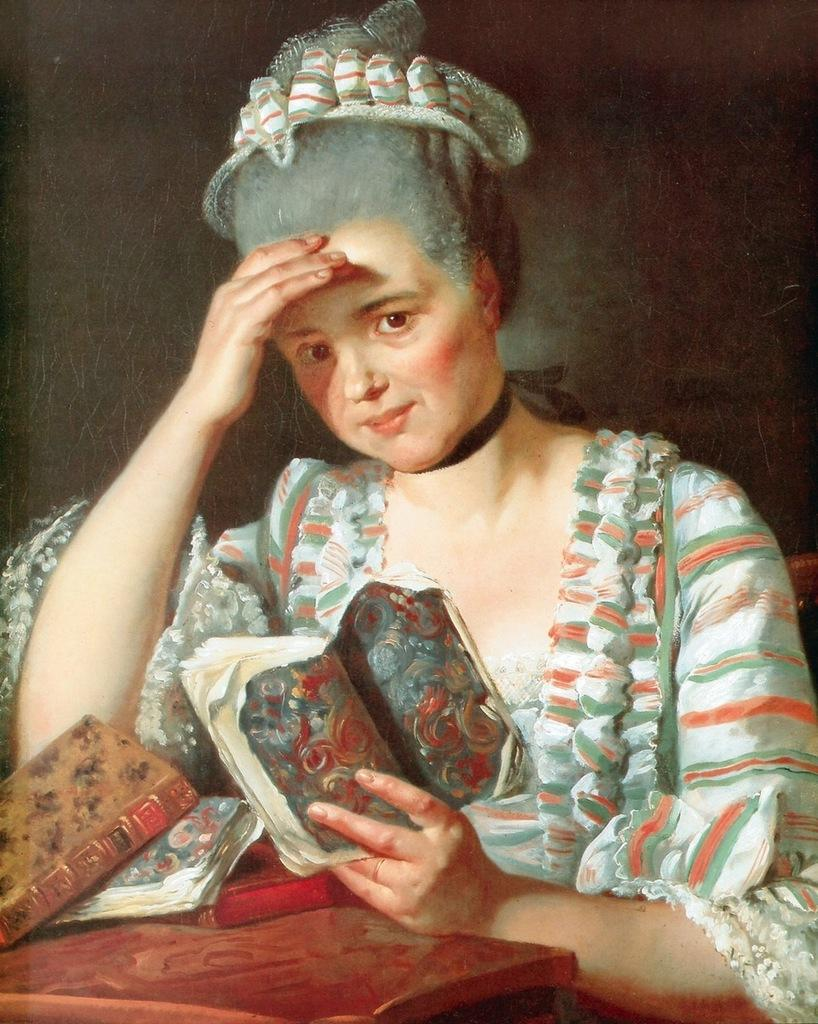Who is present in the image? There is a woman in the image. What is the woman holding? The woman is holding a book. What can be seen on the table in the image? There are objects visible on a table in the image. What type of hat is the woman wearing in the image? There is no hat visible in the image; the woman is holding a book. 